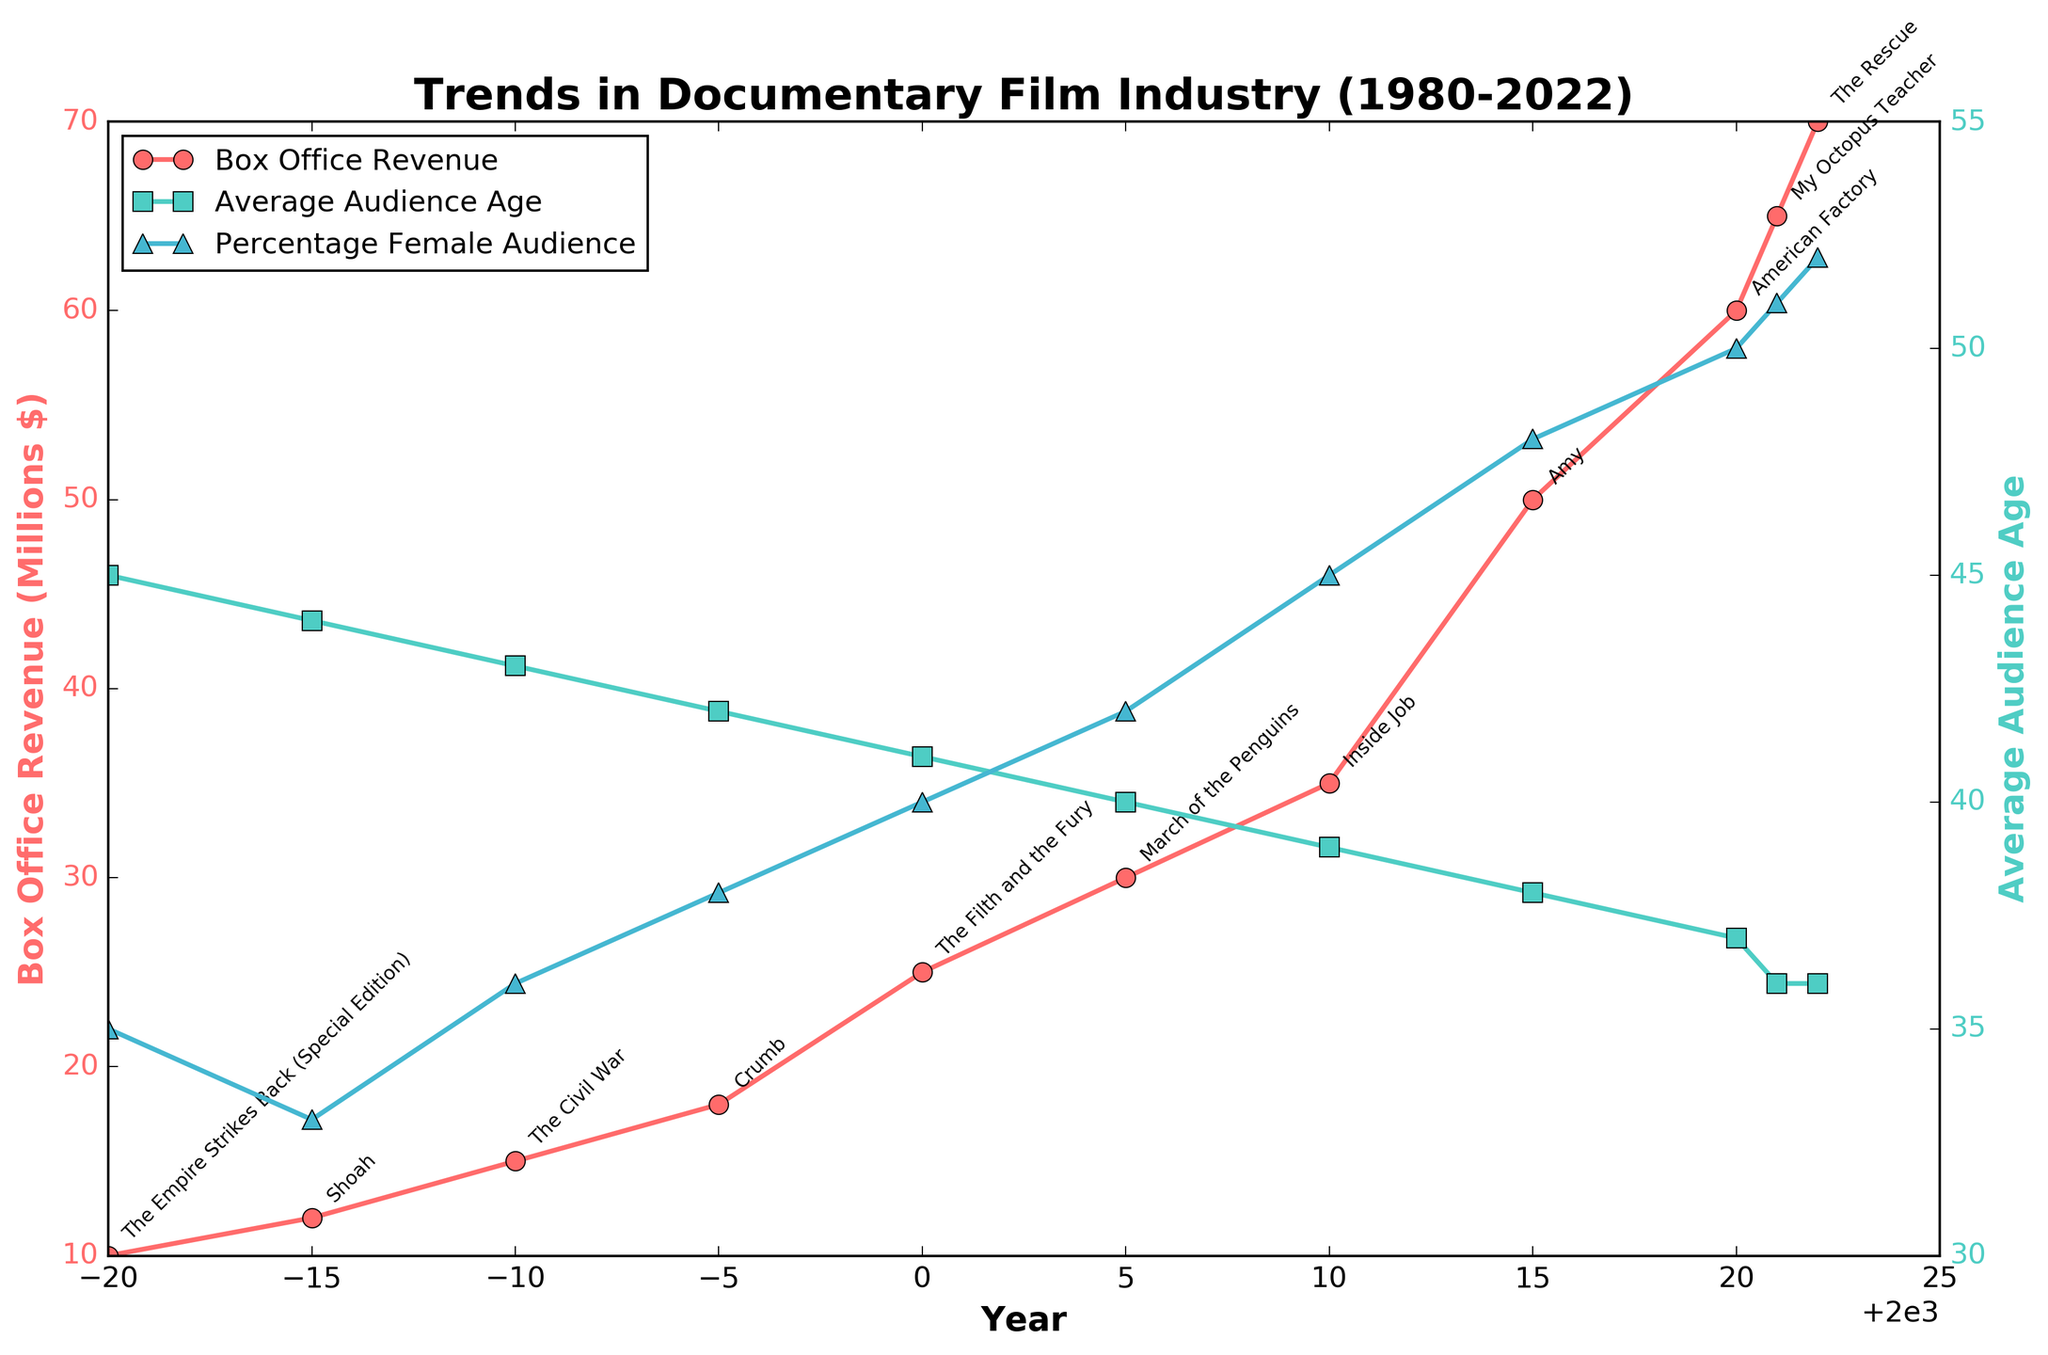What's the title of the plot? The title is displayed at the top of the figure and indicates the theme of the plot. The title of this plot is "Trends in Documentary Film Industry (1980-2022)"
Answer: Trends in Documentary Film Industry (1980-2022) How does the Box Office Revenue trend change from 1980 to 2022? The line for Box Office Revenue, represented by red markers, shows an increasing trend from 1980 ($10 million) to 2022 ($70 million). This suggests a growth in revenues over the years.
Answer: Increasing What are the colors used to represent 'Box Office Revenue', 'Average Audience Age', and 'Percentage Female Audience'? The plot uses different colors for each metric to distinguish them clearly. 'Box Office Revenue' is represented by red, 'Average Audience Age' by turquoise, and 'Percentage Female Audience' by blue.
Answer: Red, Turquoise, Blue Which year had the highest Box Office Revenue for documentary films? The highest point on the red line representing Box Office Revenue occurs in 2022, where the revenue is $70 million.
Answer: 2022 What was the Average Audience Age trend from 1980 to 2022? The turquoise line for Average Audience Age shows a decreasing trend from 1980 (45 years) to 2022 (36 years), indicating documentary viewers are getting younger over the years.
Answer: Decreasing How did the Percentage Female Audience change between 2010 and 2022? The blue line for Percentage Female Audience shows data points increasing from 2010 (45%) to 2022 (52%), showing an increase in female documentary viewers.
Answer: Increased Which two years have the same Average Audience Age and what is that age? The turquoise line shows data points indicating that both 2021 and 2022 had the same Average Audience Age of 36.
Answer: 2021, 2022; 36 Which documentary had the highest box office revenue and in what year? The top-grossing documentary in the year with the highest revenue (2022) is annotated as "The Rescue".
Answer: The Rescue, 2022 What was the box office revenue in the year 2005, and what was the top-grossing documentary that year? By locating the data point for 2005 on the red line, the Box Office Revenue is $30 million, and the annotation shows the top grossing documentary was "March of the Penguins."
Answer: $30 million, March of the Penguins Compare the Box Office Revenue in 1990 and 2020. How much did it increase? The revenue in 1990 was $15 million and in 2020 it was $60 million. The increase is calculated by subtracting the two values: $60 million - $15 million = $45 million.
Answer: $45 million 